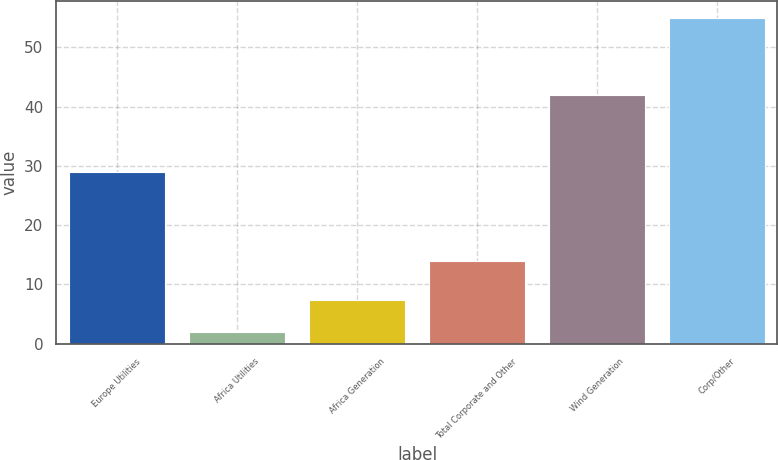Convert chart. <chart><loc_0><loc_0><loc_500><loc_500><bar_chart><fcel>Europe Utilities<fcel>Africa Utilities<fcel>Africa Generation<fcel>Total Corporate and Other<fcel>Wind Generation<fcel>Corp/Other<nl><fcel>29<fcel>2<fcel>7.3<fcel>14<fcel>42<fcel>55<nl></chart> 